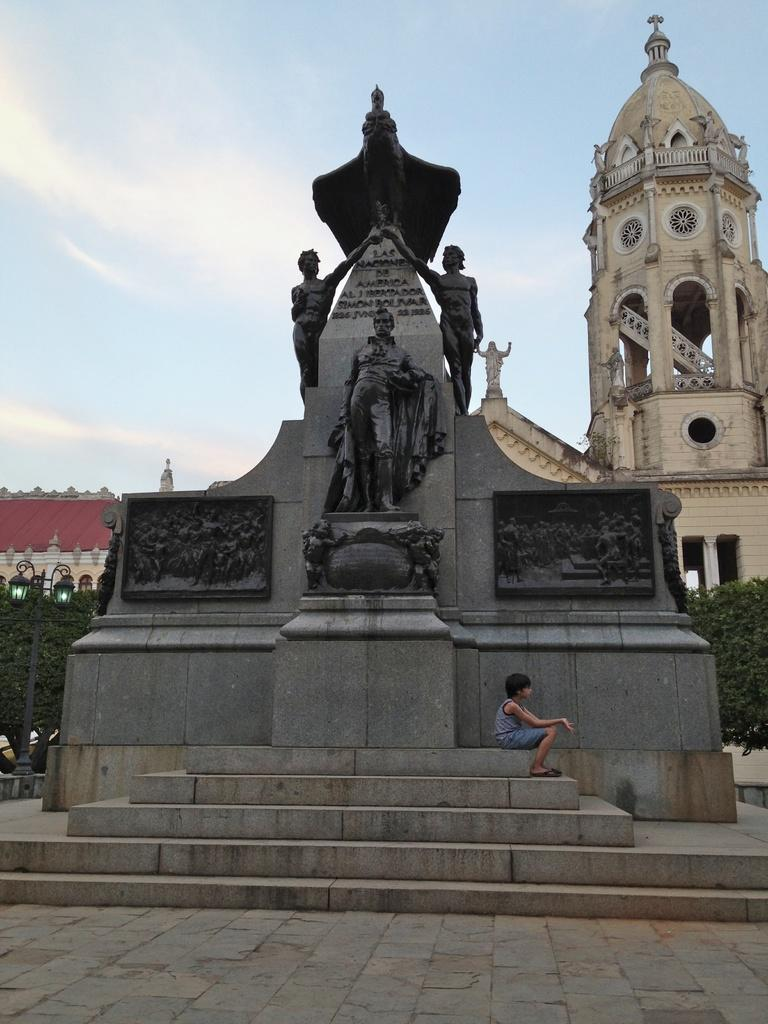What is the main subject of the image? There is a big sculpture in the image. What is located in front of the sculpture? There are steps in front of the sculpture. What is the person in the image doing? There is a person sitting in front of the sculpture. What type of vegetation can be seen in the image? There are plants visible in the image. What can be seen in the background of the image? There is a building in the background of the image. What is the name of the person sitting in front of the sculpture? The provided facts do not mention the name of the person sitting in front of the sculpture, so we cannot determine their name from the image. What type of spade is being used by the person sitting in front of the sculpture? There is no spade visible in the image, and the person sitting in front of the sculpture is not using any tool. 